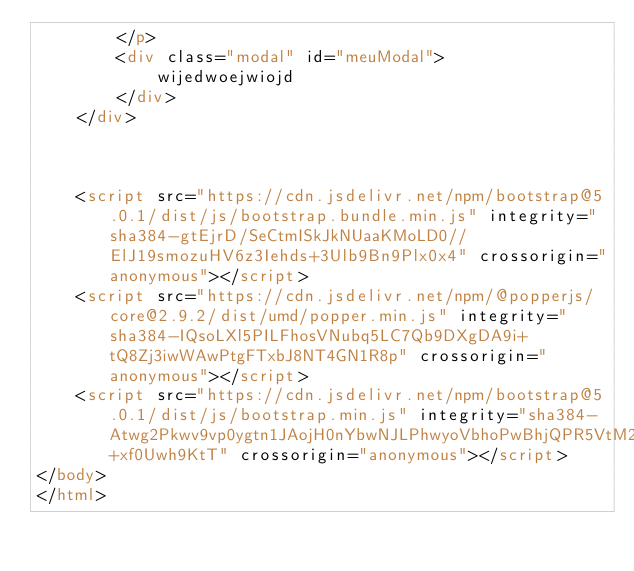Convert code to text. <code><loc_0><loc_0><loc_500><loc_500><_HTML_>        </p>
        <div class="modal" id="meuModal">
            wijedwoejwiojd
        </div>
    </div>



    <script src="https://cdn.jsdelivr.net/npm/bootstrap@5.0.1/dist/js/bootstrap.bundle.min.js" integrity="sha384-gtEjrD/SeCtmISkJkNUaaKMoLD0//ElJ19smozuHV6z3Iehds+3Ulb9Bn9Plx0x4" crossorigin="anonymous"></script>
    <script src="https://cdn.jsdelivr.net/npm/@popperjs/core@2.9.2/dist/umd/popper.min.js" integrity="sha384-IQsoLXl5PILFhosVNubq5LC7Qb9DXgDA9i+tQ8Zj3iwWAwPtgFTxbJ8NT4GN1R8p" crossorigin="anonymous"></script>
    <script src="https://cdn.jsdelivr.net/npm/bootstrap@5.0.1/dist/js/bootstrap.min.js" integrity="sha384-Atwg2Pkwv9vp0ygtn1JAojH0nYbwNJLPhwyoVbhoPwBhjQPR5VtM2+xf0Uwh9KtT" crossorigin="anonymous"></script>
</body>
</html></code> 